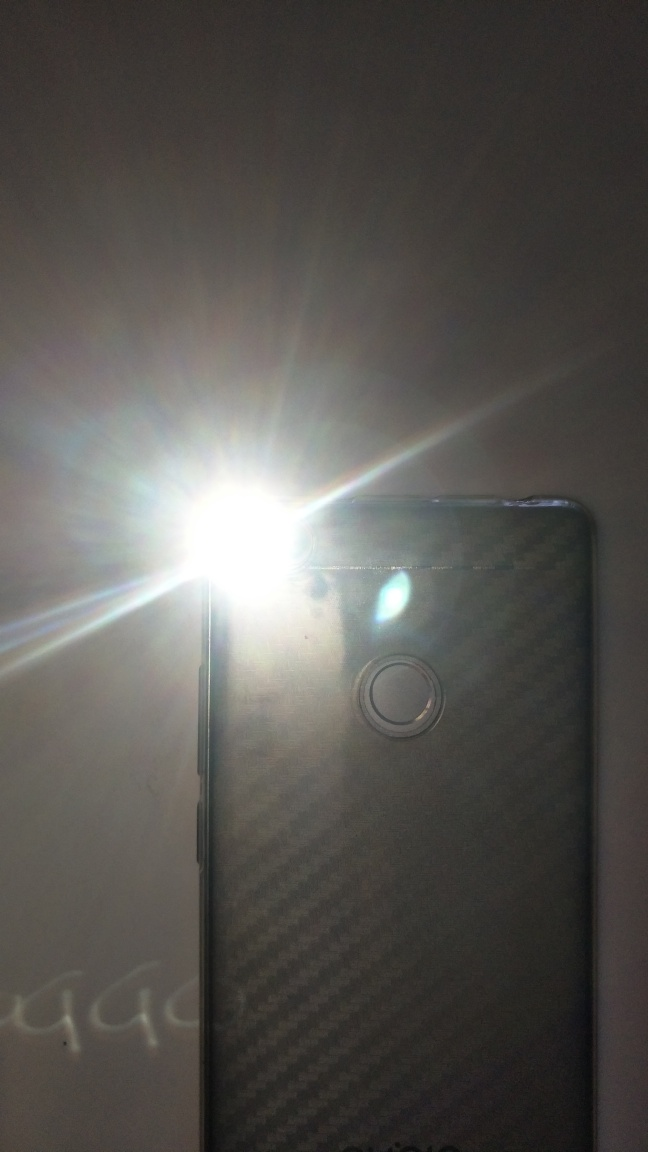Is the main subject a phone and flash?
A. No
B. Yes
Answer with the option's letter from the given choices directly.
 B. 